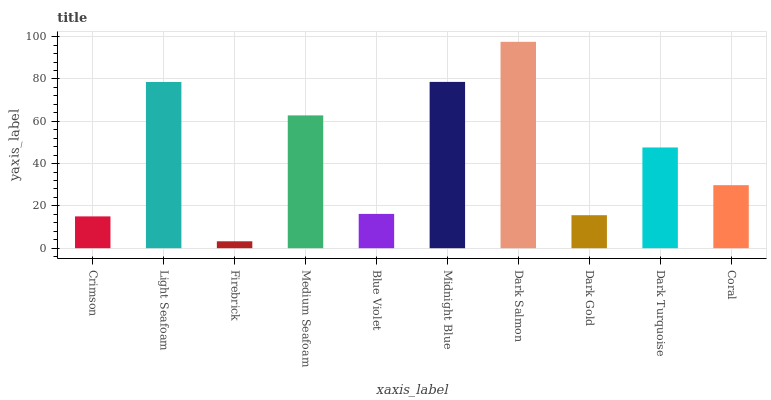Is Firebrick the minimum?
Answer yes or no. Yes. Is Dark Salmon the maximum?
Answer yes or no. Yes. Is Light Seafoam the minimum?
Answer yes or no. No. Is Light Seafoam the maximum?
Answer yes or no. No. Is Light Seafoam greater than Crimson?
Answer yes or no. Yes. Is Crimson less than Light Seafoam?
Answer yes or no. Yes. Is Crimson greater than Light Seafoam?
Answer yes or no. No. Is Light Seafoam less than Crimson?
Answer yes or no. No. Is Dark Turquoise the high median?
Answer yes or no. Yes. Is Coral the low median?
Answer yes or no. Yes. Is Crimson the high median?
Answer yes or no. No. Is Blue Violet the low median?
Answer yes or no. No. 